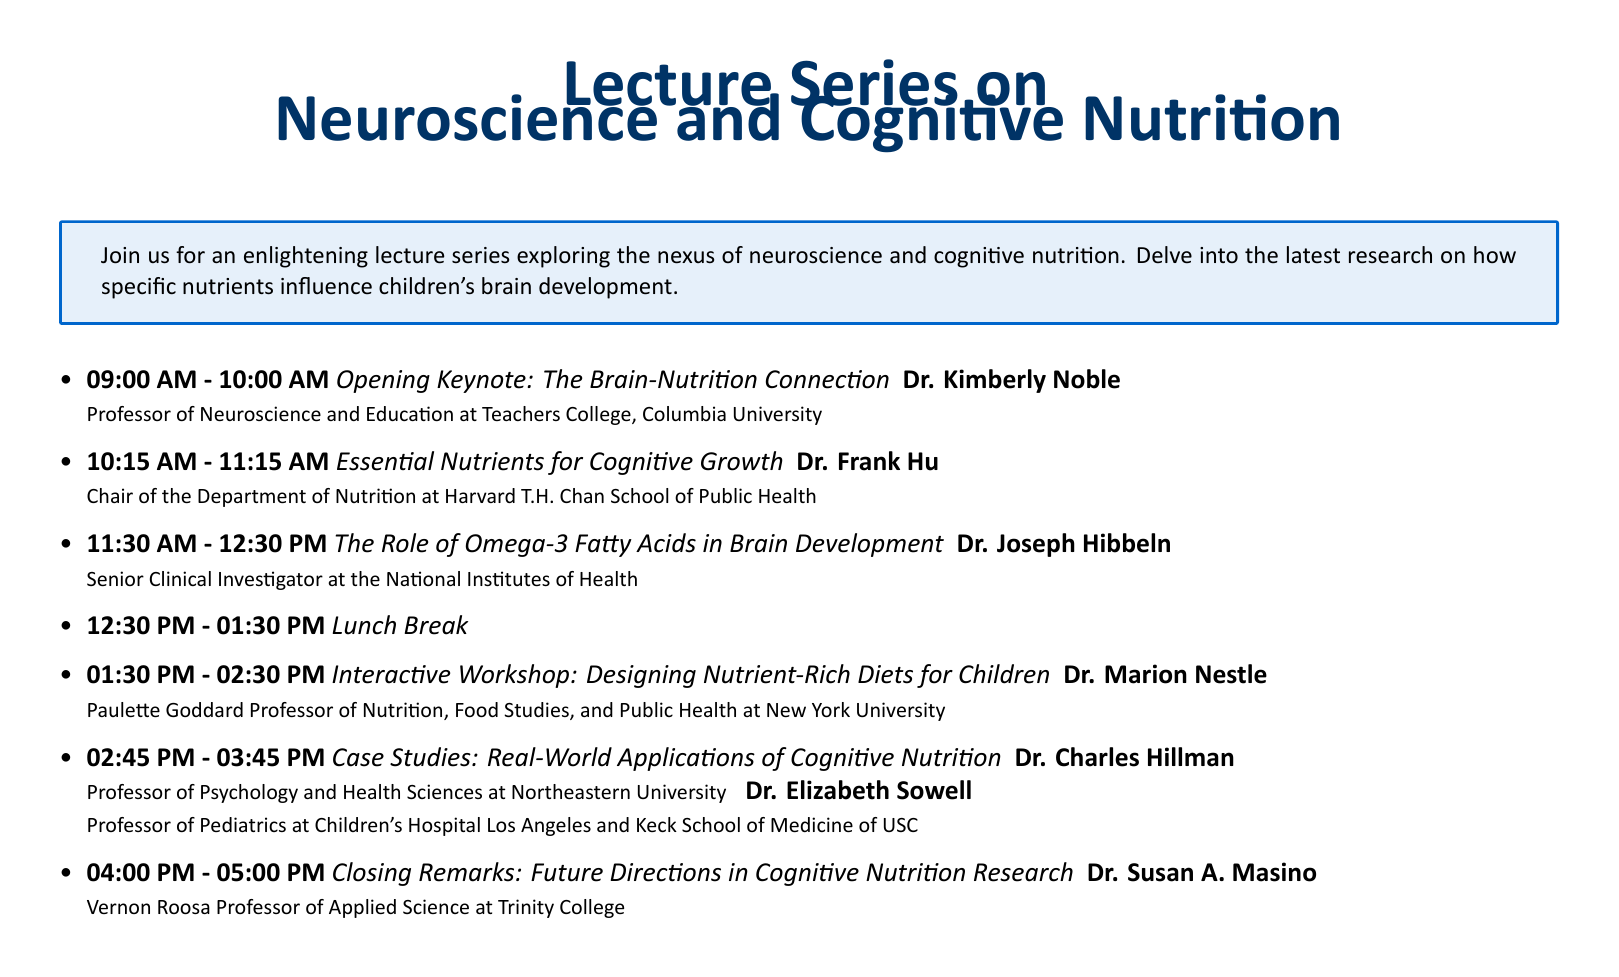What time does the opening keynote start? The opening keynote starts at 09:00 AM, as stated in the schedule.
Answer: 09:00 AM Who is speaking about essential nutrients for cognitive growth? Dr. Frank Hu is the speaker for this session, as mentioned in the document.
Answer: Dr. Frank Hu What is the title of Dr. Joseph Hibbeln's session? Dr. Joseph Hibbeln's session is titled "The Role of Omega-3 Fatty Acids in Brain Development".
Answer: The Role of Omega-3 Fatty Acids in Brain Development How long is the lunch break scheduled for? The lunch break is scheduled for one hour, as indicated in the document.
Answer: 01:00 hour Which university is Dr. Marion Nestle associated with? Dr. Marion Nestle is a professor at New York University, as mentioned in her bio.
Answer: New York University What topic will be covered in the closing remarks? The closing remarks will cover "Future Directions in Cognitive Nutrition Research".
Answer: Future Directions in Cognitive Nutrition Research Who are the speakers for the case studies session? The speakers for the case studies session are Dr. Charles Hillman and Dr. Elizabeth Sowell.
Answer: Dr. Charles Hillman and Dr. Elizabeth Sowell What is the main focus of this lecture series? The main focus of the lecture series is the relationship between neuroscience and cognitive nutrition.
Answer: Neuroscience and cognitive nutrition 